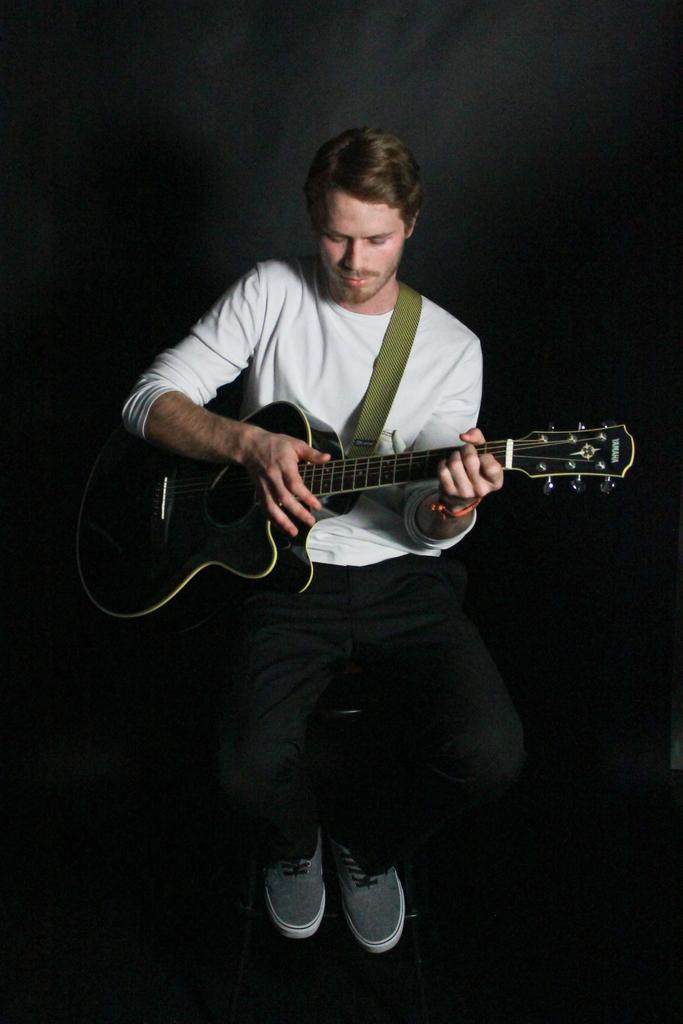Who is the main subject in the image? There is a man in the image. What is the man wearing? The man is wearing a white shirt. What object is the man holding? The man is holding a guitar. What is the man doing with the guitar? The man is playing the guitar. What type of glove can be seen on the man's hand in the image? There is no glove present on the man's hand in the image. What sound can be heard coming from the guitar in the image? The image is a still image, so no sound can be heard. 